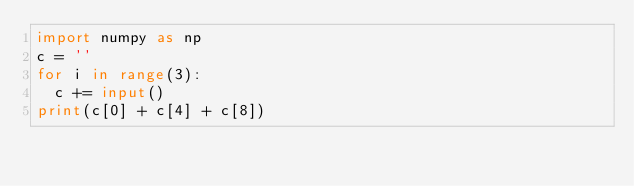<code> <loc_0><loc_0><loc_500><loc_500><_Python_>import numpy as np
c = ''
for i in range(3):
  c += input()
print(c[0] + c[4] + c[8])</code> 